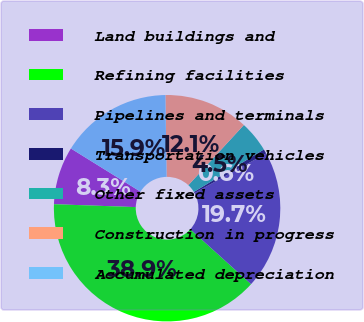Convert chart. <chart><loc_0><loc_0><loc_500><loc_500><pie_chart><fcel>Land buildings and<fcel>Refining facilities<fcel>Pipelines and terminals<fcel>Transportation vehicles<fcel>Other fixed assets<fcel>Construction in progress<fcel>Accumulated depreciation<nl><fcel>8.28%<fcel>38.86%<fcel>19.75%<fcel>0.64%<fcel>4.46%<fcel>12.1%<fcel>15.92%<nl></chart> 